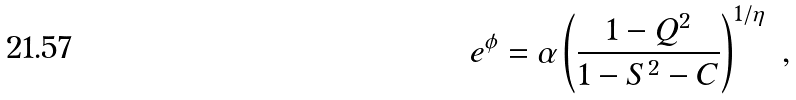<formula> <loc_0><loc_0><loc_500><loc_500>e ^ { \phi } = \alpha \left ( \frac { 1 - Q ^ { 2 } } { 1 - S ^ { 2 } - C } \right ) ^ { 1 / \eta } \ ,</formula> 